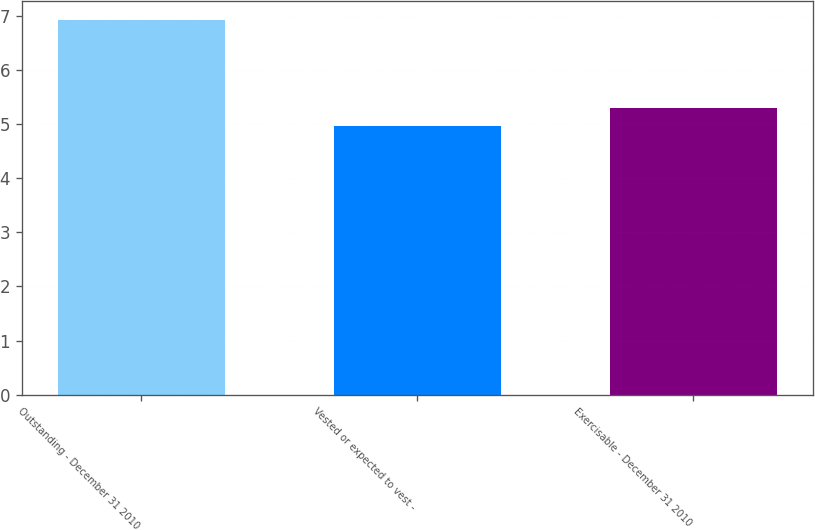Convert chart to OTSL. <chart><loc_0><loc_0><loc_500><loc_500><bar_chart><fcel>Outstanding - December 31 2010<fcel>Vested or expected to vest -<fcel>Exercisable - December 31 2010<nl><fcel>6.93<fcel>4.97<fcel>5.3<nl></chart> 